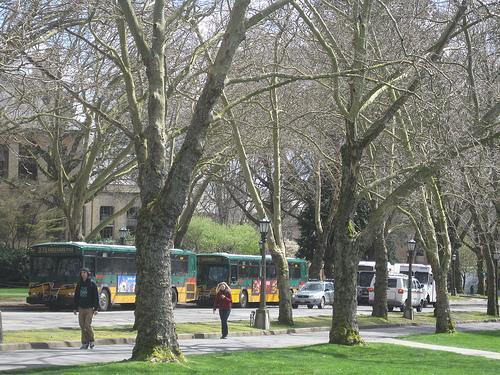How many buses are on the street?
Give a very brief answer. 2. How many people are on the sidewalk?
Give a very brief answer. 2. How many street lights?
Give a very brief answer. 2. 